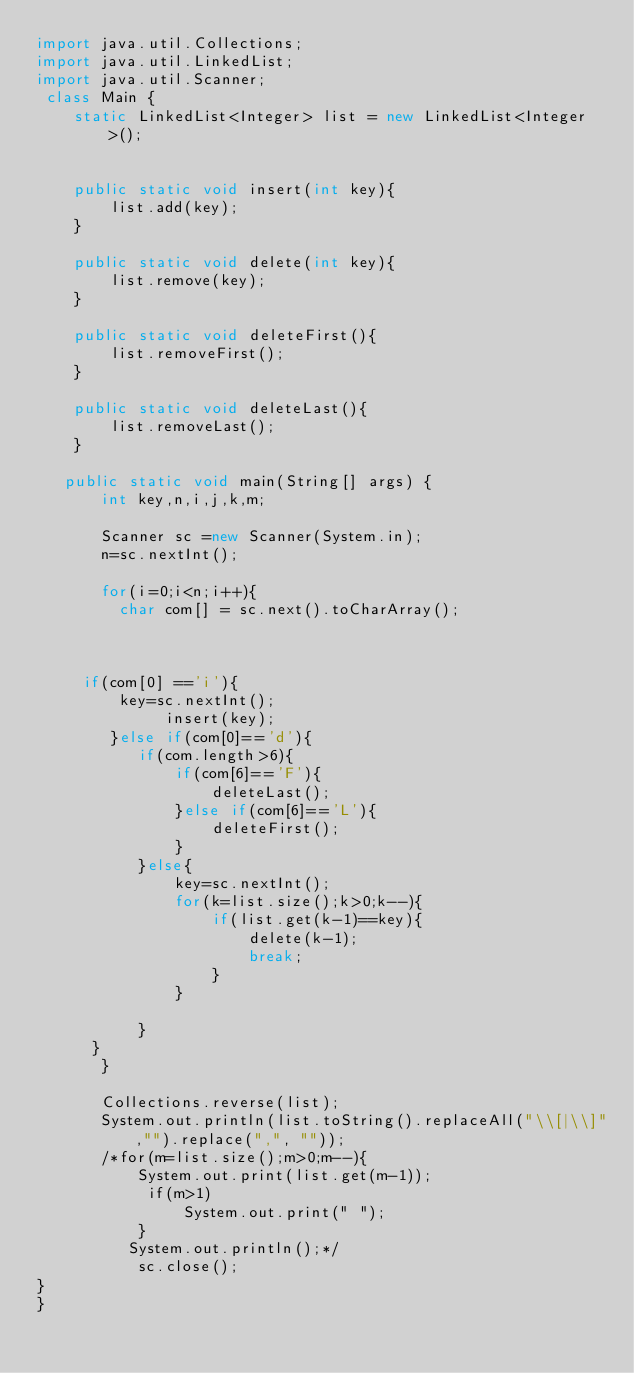<code> <loc_0><loc_0><loc_500><loc_500><_Java_>import java.util.Collections;
import java.util.LinkedList;
import java.util.Scanner;
 class Main {
	static LinkedList<Integer> list = new LinkedList<Integer>();
	
	
	public static void insert(int key){
		list.add(key);
	}
	
	public static void delete(int key){
		list.remove(key);
	}
	
	public static void deleteFirst(){
		list.removeFirst();
	}
	
	public static void deleteLast(){
		list.removeLast();
	}
	
   public static void main(String[] args) {
	   int key,n,i,j,k,m;
	   
	   Scanner sc =new Scanner(System.in);
	   n=sc.nextInt();
	   
	   for(i=0;i<n;i++){
		 char com[] = sc.next().toCharArray();  
		 
		 
	  
	 if(com[0] =='i'){
		 key=sc.nextInt();
			  insert(key);
	    }else if(com[0]=='d'){
		   if(com.length>6){
			   if(com[6]=='F'){
				   deleteLast();
			   }else if(com[6]=='L'){
				   deleteFirst();
			   }
		   }else{
			   key=sc.nextInt();
			   for(k=list.size();k>0;k--){
				   if(list.get(k-1)==key){
					   delete(k-1);
					   break;
				   }
			   }
			   
		   }
	  } 
	   }
	   
	   Collections.reverse(list);
	   System.out.println(list.toString().replaceAll("\\[|\\]","").replace(",", ""));
	   /*for(m=list.size();m>0;m--){  
		   System.out.print(list.get(m-1));
	        if(m>1)
	            System.out.print(" ");
		   }
		  System.out.println();*/
		   sc.close();
}
}</code> 